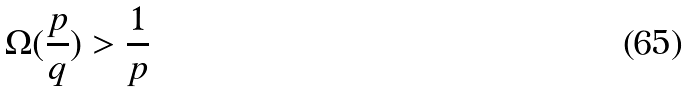Convert formula to latex. <formula><loc_0><loc_0><loc_500><loc_500>\Omega ( \frac { p } { q } ) > \frac { 1 } { p }</formula> 